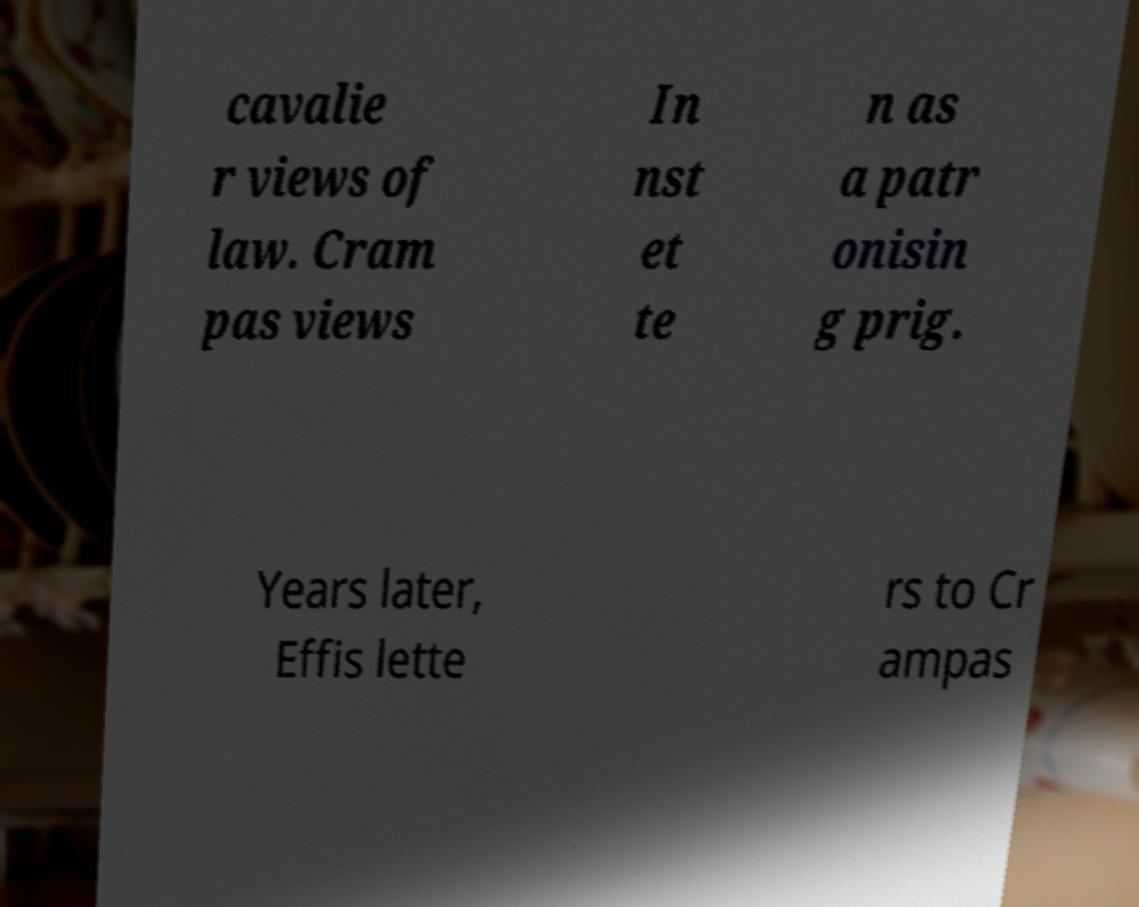Could you assist in decoding the text presented in this image and type it out clearly? cavalie r views of law. Cram pas views In nst et te n as a patr onisin g prig. Years later, Effis lette rs to Cr ampas 